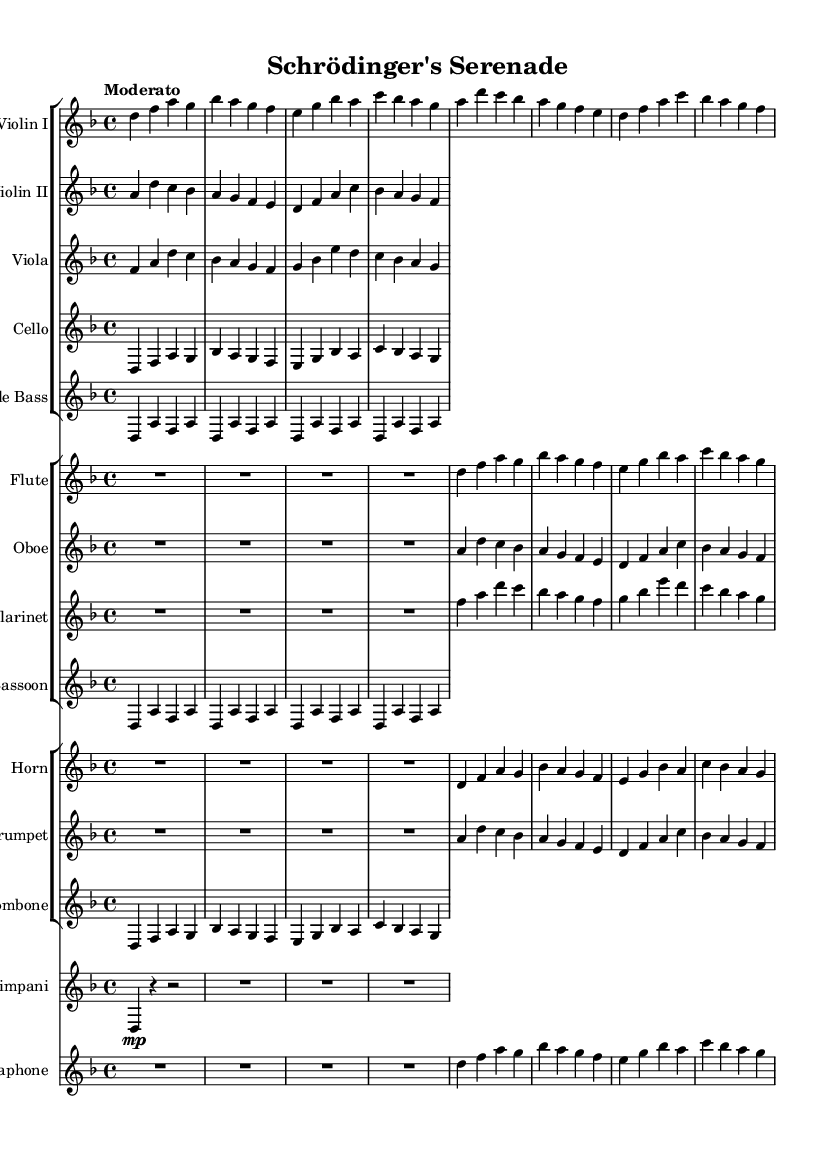What is the key signature of this music? The key signature is indicated at the beginning of the sheet music. In this case, it is written as "d" suggesting that there are two flats (B flat and E flat) for D minor.
Answer: D minor What is the time signature of this piece? The time signature appears at the start of the sheet music just after the key signature. It is indicated as "4/4," meaning there are four beats in a measure and the quarter note receives one beat.
Answer: 4/4 What is the tempo marking for this symphony? The tempo marking is the word “Moderato” found at the beginning of the score, indicating a moderate speed for the music.
Answer: Moderato How many main sections are there in the orchestration of this symphony? By analyzing the layout of the score, we can see that there are two separate StaffGroups for string instruments and woodwinds, and then a grouped section for brass instruments. This totals four distinct groups, indicating four main sections.
Answer: Four What instrument plays the melodic line primarily? Looking at the score, the Violin I part is positioned at the top of the first StaffGroup and generally plays the leading melodic lines in orchestral arrangements, making it the primary instrument in this piece.
Answer: Violin I What is the highest pitch instrument in this sheet music? The highest-pitched notes are typically played by the Flute, which is positioned at the top of the woodwinds and generally has the range to play the highest notes within the orchestral setting.
Answer: Flute Which section features the Timpani? Timpani is shown as a separate staff towards the end of the orchestration, opposite to the strings and woodwinds. Its distinct presence indicates a specific section for it, separate from the others.
Answer: Timpani 